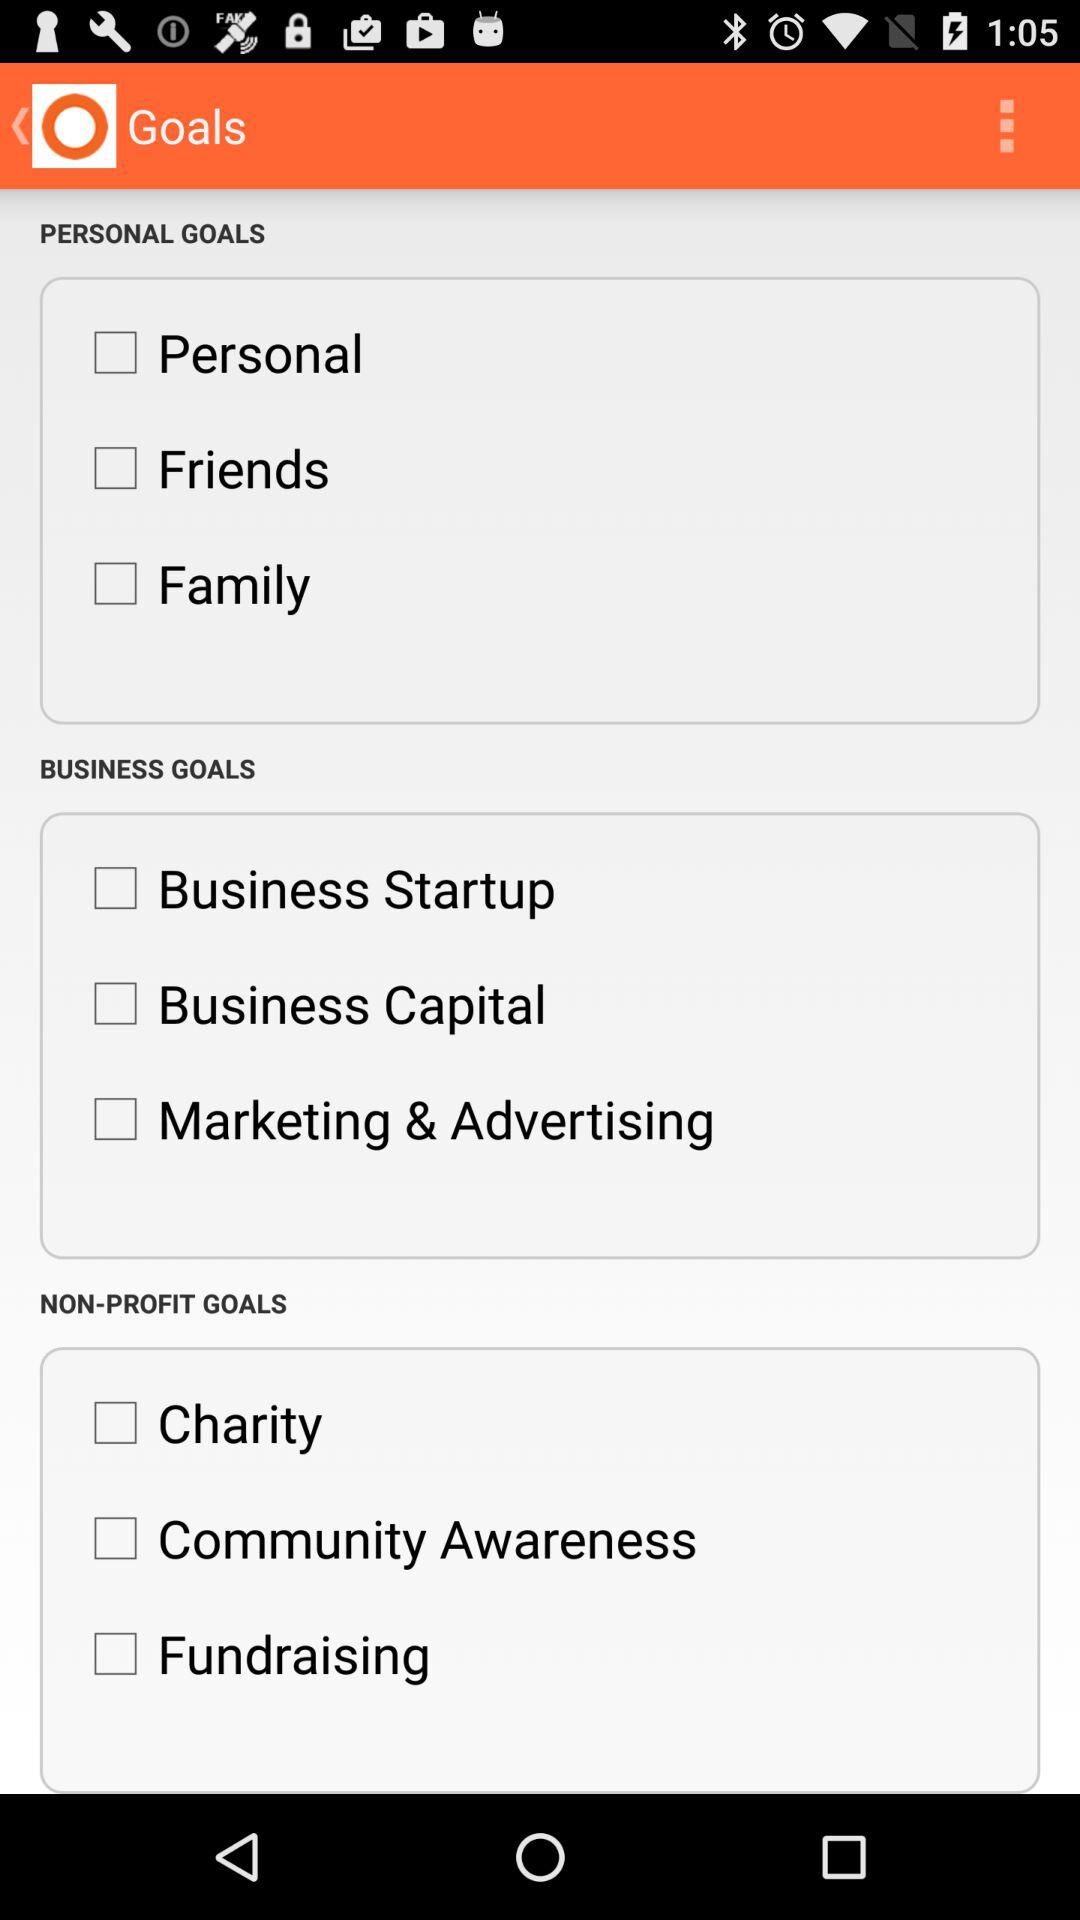What is the status of "Business Capital"? The status of "Business Capital" is "off". 